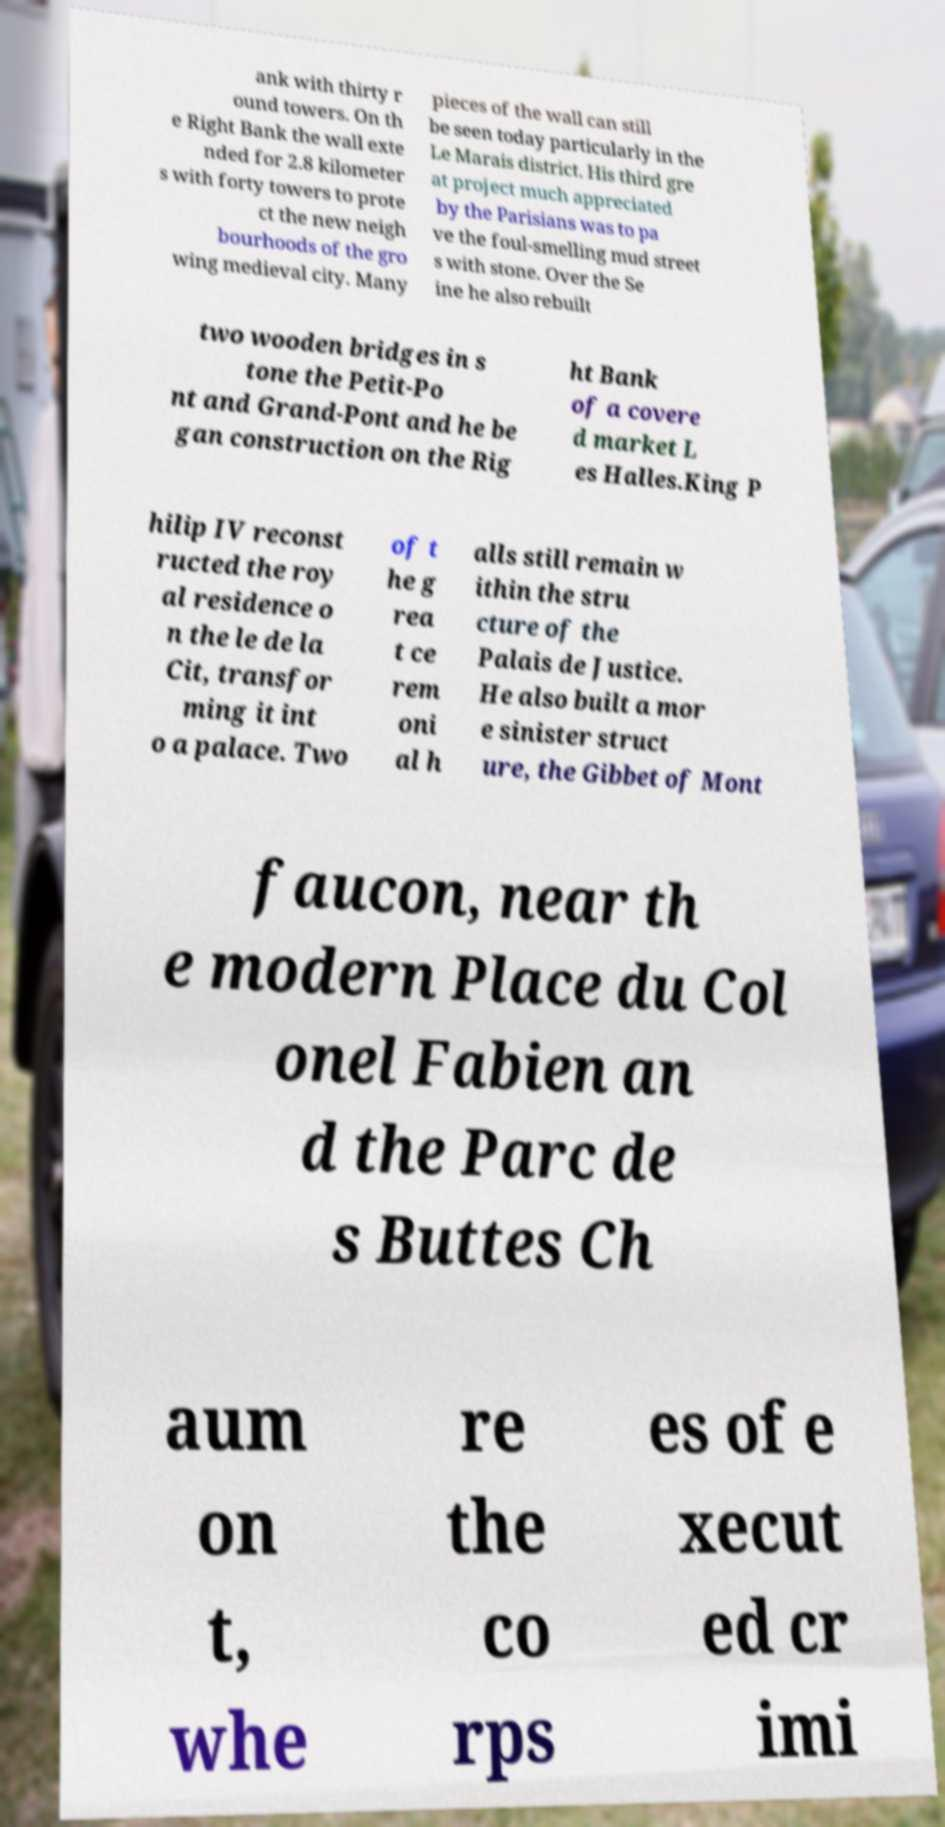There's text embedded in this image that I need extracted. Can you transcribe it verbatim? ank with thirty r ound towers. On th e Right Bank the wall exte nded for 2.8 kilometer s with forty towers to prote ct the new neigh bourhoods of the gro wing medieval city. Many pieces of the wall can still be seen today particularly in the Le Marais district. His third gre at project much appreciated by the Parisians was to pa ve the foul-smelling mud street s with stone. Over the Se ine he also rebuilt two wooden bridges in s tone the Petit-Po nt and Grand-Pont and he be gan construction on the Rig ht Bank of a covere d market L es Halles.King P hilip IV reconst ructed the roy al residence o n the le de la Cit, transfor ming it int o a palace. Two of t he g rea t ce rem oni al h alls still remain w ithin the stru cture of the Palais de Justice. He also built a mor e sinister struct ure, the Gibbet of Mont faucon, near th e modern Place du Col onel Fabien an d the Parc de s Buttes Ch aum on t, whe re the co rps es of e xecut ed cr imi 